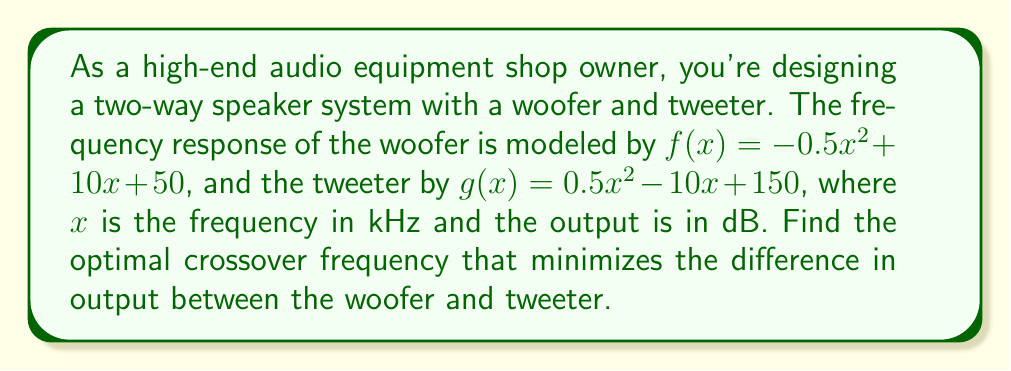What is the answer to this math problem? 1) The difference in output between the woofer and tweeter is given by:
   $h(x) = f(x) - g(x) = (-0.5x^2 + 10x + 50) - (0.5x^2 - 10x + 150)$
   
2) Simplify $h(x)$:
   $h(x) = -0.5x^2 + 10x + 50 - 0.5x^2 + 10x - 150$
   $h(x) = -x^2 + 20x - 100$

3) To minimize $h(x)$, we need to find where its derivative equals zero:
   $h'(x) = -2x + 20$

4) Set $h'(x) = 0$ and solve for $x$:
   $-2x + 20 = 0$
   $-2x = -20$
   $x = 10$

5) Verify this is a minimum by checking the second derivative:
   $h''(x) = -2$, which is negative, confirming a maximum.

6) Therefore, the optimal crossover frequency is 10 kHz.
Answer: 10 kHz 